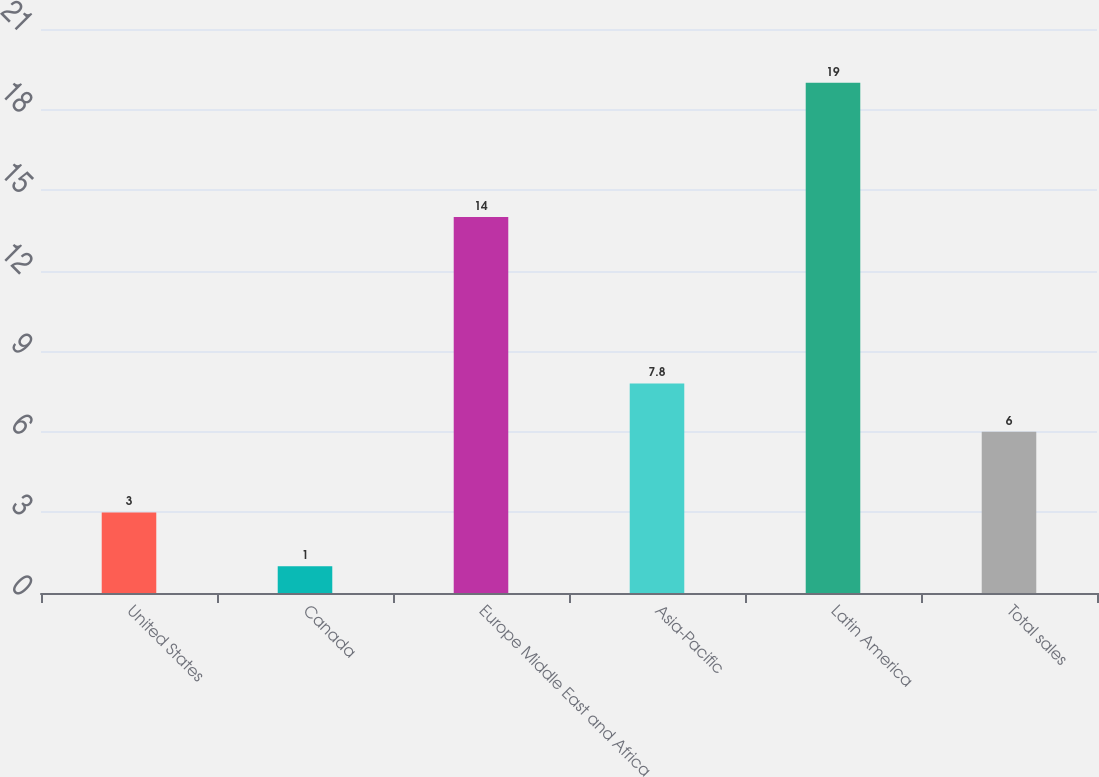Convert chart to OTSL. <chart><loc_0><loc_0><loc_500><loc_500><bar_chart><fcel>United States<fcel>Canada<fcel>Europe Middle East and Africa<fcel>Asia-Pacific<fcel>Latin America<fcel>Total sales<nl><fcel>3<fcel>1<fcel>14<fcel>7.8<fcel>19<fcel>6<nl></chart> 